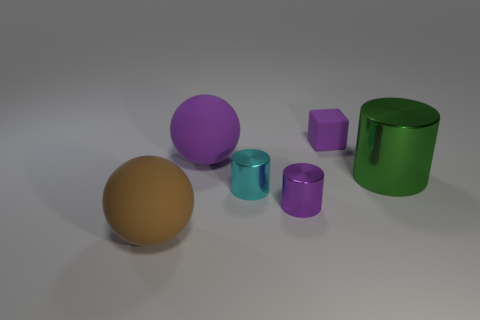Subtract all tiny cyan cylinders. How many cylinders are left? 2 Add 1 cyan things. How many objects exist? 7 Subtract all blocks. How many objects are left? 5 Add 5 small cyan cylinders. How many small cyan cylinders exist? 6 Subtract all cyan cylinders. How many cylinders are left? 2 Subtract 0 red blocks. How many objects are left? 6 Subtract 1 spheres. How many spheres are left? 1 Subtract all purple balls. Subtract all brown cylinders. How many balls are left? 1 Subtract all gray cylinders. How many brown balls are left? 1 Subtract all purple matte objects. Subtract all tiny cyan metallic objects. How many objects are left? 3 